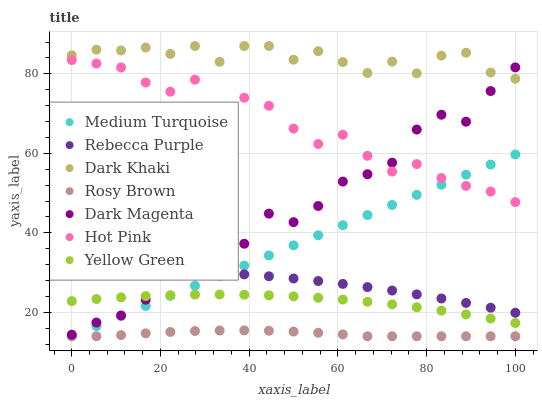Does Rosy Brown have the minimum area under the curve?
Answer yes or no. Yes. Does Dark Khaki have the maximum area under the curve?
Answer yes or no. Yes. Does Dark Magenta have the minimum area under the curve?
Answer yes or no. No. Does Dark Magenta have the maximum area under the curve?
Answer yes or no. No. Is Medium Turquoise the smoothest?
Answer yes or no. Yes. Is Dark Magenta the roughest?
Answer yes or no. Yes. Is Hot Pink the smoothest?
Answer yes or no. No. Is Hot Pink the roughest?
Answer yes or no. No. Does Rosy Brown have the lowest value?
Answer yes or no. Yes. Does Dark Magenta have the lowest value?
Answer yes or no. No. Does Dark Khaki have the highest value?
Answer yes or no. Yes. Does Dark Magenta have the highest value?
Answer yes or no. No. Is Rosy Brown less than Dark Khaki?
Answer yes or no. Yes. Is Yellow Green greater than Rosy Brown?
Answer yes or no. Yes. Does Yellow Green intersect Dark Magenta?
Answer yes or no. Yes. Is Yellow Green less than Dark Magenta?
Answer yes or no. No. Is Yellow Green greater than Dark Magenta?
Answer yes or no. No. Does Rosy Brown intersect Dark Khaki?
Answer yes or no. No. 